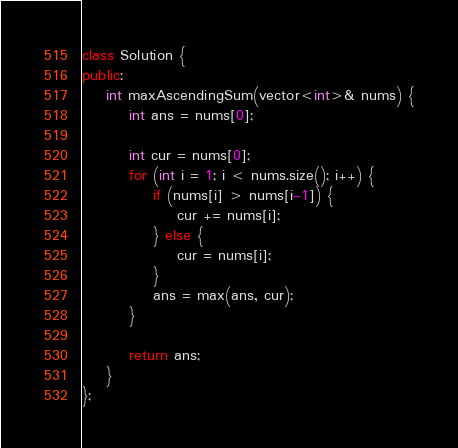Convert code to text. <code><loc_0><loc_0><loc_500><loc_500><_C++_>class Solution {
public:
    int maxAscendingSum(vector<int>& nums) {
        int ans = nums[0];
        
        int cur = nums[0];
        for (int i = 1; i < nums.size(); i++) {
            if (nums[i] > nums[i-1]) {
                cur += nums[i];
            } else {
                cur = nums[i];
            }
            ans = max(ans, cur);
        }
        
        return ans;
    }
};
</code> 